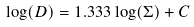<formula> <loc_0><loc_0><loc_500><loc_500>\log ( D ) = 1 . 3 3 3 \log ( \Sigma ) + C</formula> 